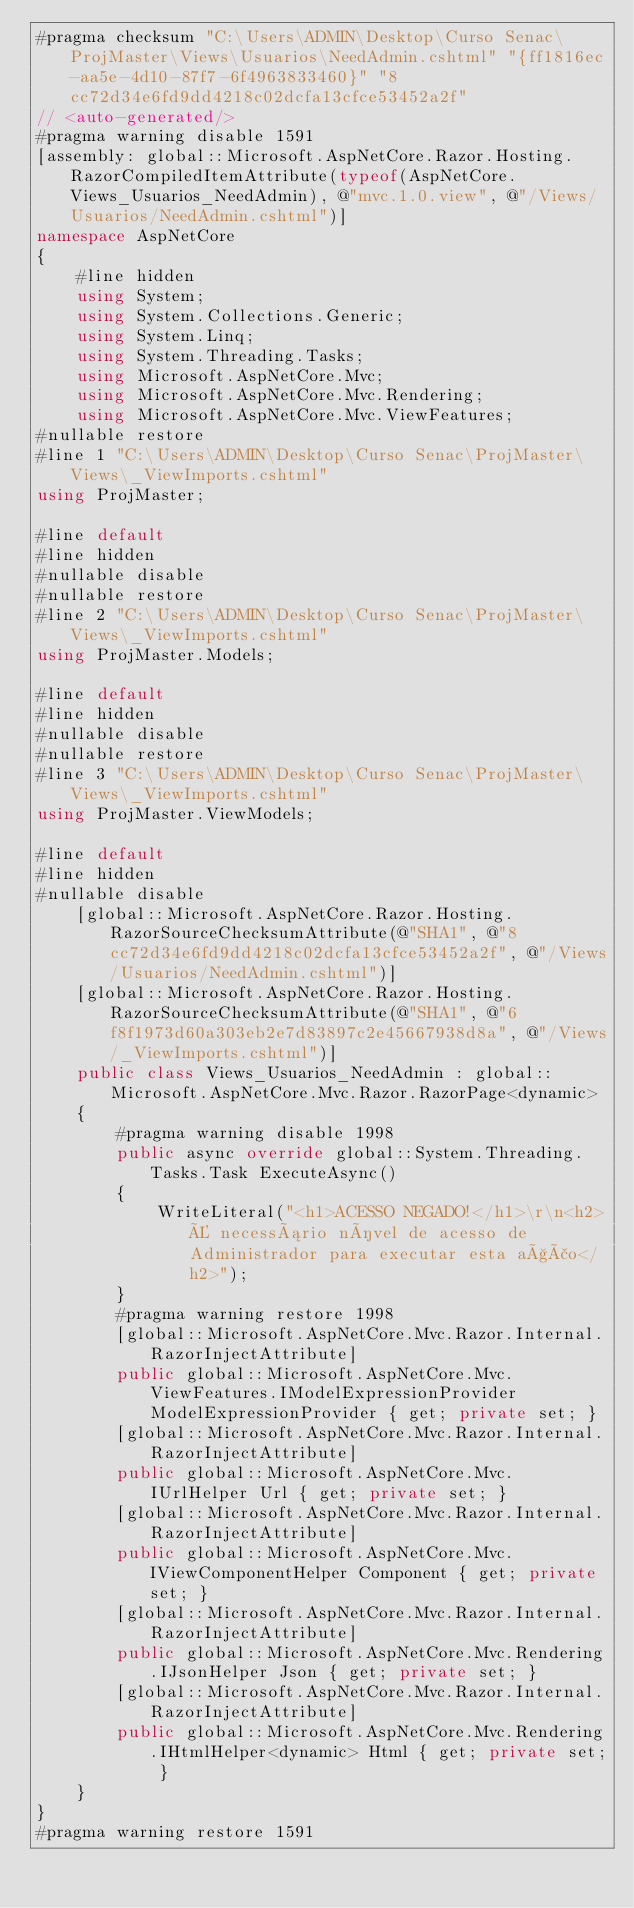<code> <loc_0><loc_0><loc_500><loc_500><_C#_>#pragma checksum "C:\Users\ADMIN\Desktop\Curso Senac\ProjMaster\Views\Usuarios\NeedAdmin.cshtml" "{ff1816ec-aa5e-4d10-87f7-6f4963833460}" "8cc72d34e6fd9dd4218c02dcfa13cfce53452a2f"
// <auto-generated/>
#pragma warning disable 1591
[assembly: global::Microsoft.AspNetCore.Razor.Hosting.RazorCompiledItemAttribute(typeof(AspNetCore.Views_Usuarios_NeedAdmin), @"mvc.1.0.view", @"/Views/Usuarios/NeedAdmin.cshtml")]
namespace AspNetCore
{
    #line hidden
    using System;
    using System.Collections.Generic;
    using System.Linq;
    using System.Threading.Tasks;
    using Microsoft.AspNetCore.Mvc;
    using Microsoft.AspNetCore.Mvc.Rendering;
    using Microsoft.AspNetCore.Mvc.ViewFeatures;
#nullable restore
#line 1 "C:\Users\ADMIN\Desktop\Curso Senac\ProjMaster\Views\_ViewImports.cshtml"
using ProjMaster;

#line default
#line hidden
#nullable disable
#nullable restore
#line 2 "C:\Users\ADMIN\Desktop\Curso Senac\ProjMaster\Views\_ViewImports.cshtml"
using ProjMaster.Models;

#line default
#line hidden
#nullable disable
#nullable restore
#line 3 "C:\Users\ADMIN\Desktop\Curso Senac\ProjMaster\Views\_ViewImports.cshtml"
using ProjMaster.ViewModels;

#line default
#line hidden
#nullable disable
    [global::Microsoft.AspNetCore.Razor.Hosting.RazorSourceChecksumAttribute(@"SHA1", @"8cc72d34e6fd9dd4218c02dcfa13cfce53452a2f", @"/Views/Usuarios/NeedAdmin.cshtml")]
    [global::Microsoft.AspNetCore.Razor.Hosting.RazorSourceChecksumAttribute(@"SHA1", @"6f8f1973d60a303eb2e7d83897c2e45667938d8a", @"/Views/_ViewImports.cshtml")]
    public class Views_Usuarios_NeedAdmin : global::Microsoft.AspNetCore.Mvc.Razor.RazorPage<dynamic>
    {
        #pragma warning disable 1998
        public async override global::System.Threading.Tasks.Task ExecuteAsync()
        {
            WriteLiteral("<h1>ACESSO NEGADO!</h1>\r\n<h2>É necessário nível de acesso de Administrador para executar esta ação</h2>");
        }
        #pragma warning restore 1998
        [global::Microsoft.AspNetCore.Mvc.Razor.Internal.RazorInjectAttribute]
        public global::Microsoft.AspNetCore.Mvc.ViewFeatures.IModelExpressionProvider ModelExpressionProvider { get; private set; }
        [global::Microsoft.AspNetCore.Mvc.Razor.Internal.RazorInjectAttribute]
        public global::Microsoft.AspNetCore.Mvc.IUrlHelper Url { get; private set; }
        [global::Microsoft.AspNetCore.Mvc.Razor.Internal.RazorInjectAttribute]
        public global::Microsoft.AspNetCore.Mvc.IViewComponentHelper Component { get; private set; }
        [global::Microsoft.AspNetCore.Mvc.Razor.Internal.RazorInjectAttribute]
        public global::Microsoft.AspNetCore.Mvc.Rendering.IJsonHelper Json { get; private set; }
        [global::Microsoft.AspNetCore.Mvc.Razor.Internal.RazorInjectAttribute]
        public global::Microsoft.AspNetCore.Mvc.Rendering.IHtmlHelper<dynamic> Html { get; private set; }
    }
}
#pragma warning restore 1591
</code> 